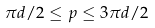<formula> <loc_0><loc_0><loc_500><loc_500>\pi d / 2 \leq p \leq 3 \pi d / 2</formula> 